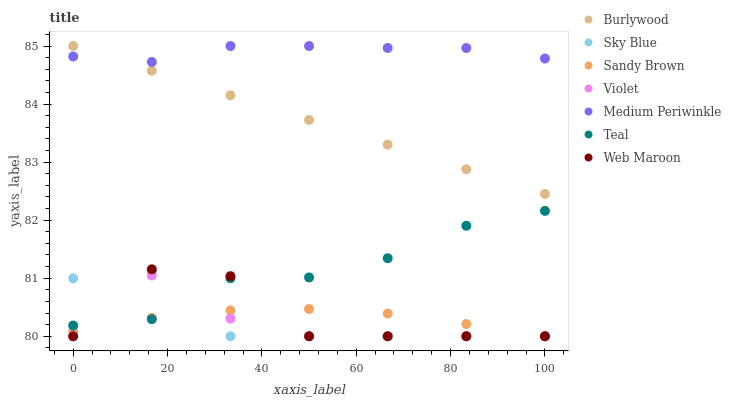Does Violet have the minimum area under the curve?
Answer yes or no. Yes. Does Medium Periwinkle have the maximum area under the curve?
Answer yes or no. Yes. Does Web Maroon have the minimum area under the curve?
Answer yes or no. No. Does Web Maroon have the maximum area under the curve?
Answer yes or no. No. Is Burlywood the smoothest?
Answer yes or no. Yes. Is Web Maroon the roughest?
Answer yes or no. Yes. Is Medium Periwinkle the smoothest?
Answer yes or no. No. Is Medium Periwinkle the roughest?
Answer yes or no. No. Does Web Maroon have the lowest value?
Answer yes or no. Yes. Does Medium Periwinkle have the lowest value?
Answer yes or no. No. Does Medium Periwinkle have the highest value?
Answer yes or no. Yes. Does Web Maroon have the highest value?
Answer yes or no. No. Is Sandy Brown less than Medium Periwinkle?
Answer yes or no. Yes. Is Burlywood greater than Web Maroon?
Answer yes or no. Yes. Does Violet intersect Sky Blue?
Answer yes or no. Yes. Is Violet less than Sky Blue?
Answer yes or no. No. Is Violet greater than Sky Blue?
Answer yes or no. No. Does Sandy Brown intersect Medium Periwinkle?
Answer yes or no. No. 